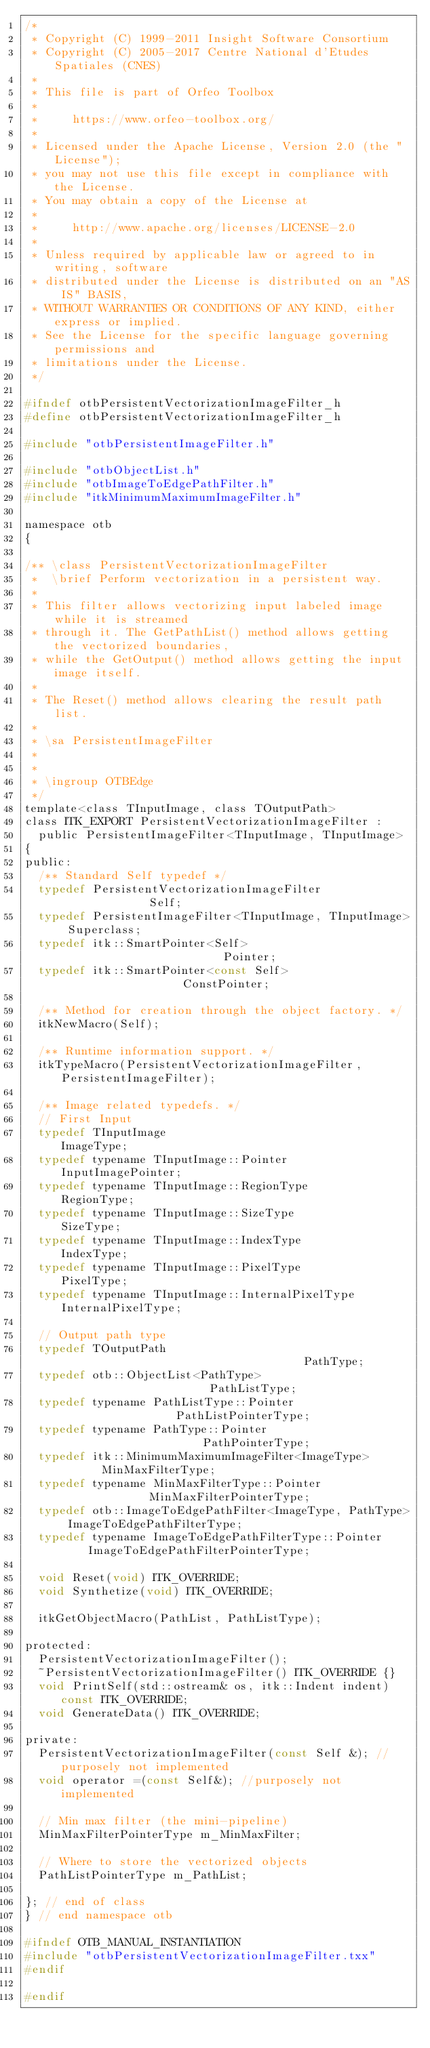Convert code to text. <code><loc_0><loc_0><loc_500><loc_500><_C_>/*
 * Copyright (C) 1999-2011 Insight Software Consortium
 * Copyright (C) 2005-2017 Centre National d'Etudes Spatiales (CNES)
 *
 * This file is part of Orfeo Toolbox
 *
 *     https://www.orfeo-toolbox.org/
 *
 * Licensed under the Apache License, Version 2.0 (the "License");
 * you may not use this file except in compliance with the License.
 * You may obtain a copy of the License at
 *
 *     http://www.apache.org/licenses/LICENSE-2.0
 *
 * Unless required by applicable law or agreed to in writing, software
 * distributed under the License is distributed on an "AS IS" BASIS,
 * WITHOUT WARRANTIES OR CONDITIONS OF ANY KIND, either express or implied.
 * See the License for the specific language governing permissions and
 * limitations under the License.
 */

#ifndef otbPersistentVectorizationImageFilter_h
#define otbPersistentVectorizationImageFilter_h

#include "otbPersistentImageFilter.h"

#include "otbObjectList.h"
#include "otbImageToEdgePathFilter.h"
#include "itkMinimumMaximumImageFilter.h"

namespace otb
{

/** \class PersistentVectorizationImageFilter
 *  \brief Perform vectorization in a persistent way.
 *
 * This filter allows vectorizing input labeled image while it is streamed
 * through it. The GetPathList() method allows getting the vectorized boundaries,
 * while the GetOutput() method allows getting the input image itself.
 *
 * The Reset() method allows clearing the result path list.
 *
 * \sa PersistentImageFilter
 *
 *
 * \ingroup OTBEdge
 */
template<class TInputImage, class TOutputPath>
class ITK_EXPORT PersistentVectorizationImageFilter :
  public PersistentImageFilter<TInputImage, TInputImage>
{
public:
  /** Standard Self typedef */
  typedef PersistentVectorizationImageFilter              Self;
  typedef PersistentImageFilter<TInputImage, TInputImage> Superclass;
  typedef itk::SmartPointer<Self>                         Pointer;
  typedef itk::SmartPointer<const Self>                   ConstPointer;

  /** Method for creation through the object factory. */
  itkNewMacro(Self);

  /** Runtime information support. */
  itkTypeMacro(PersistentVectorizationImageFilter, PersistentImageFilter);

  /** Image related typedefs. */
  // First Input
  typedef TInputImage                             ImageType;
  typedef typename TInputImage::Pointer           InputImagePointer;
  typedef typename TInputImage::RegionType        RegionType;
  typedef typename TInputImage::SizeType          SizeType;
  typedef typename TInputImage::IndexType         IndexType;
  typedef typename TInputImage::PixelType         PixelType;
  typedef typename TInputImage::InternalPixelType InternalPixelType;

  // Output path type
  typedef TOutputPath                                     PathType;
  typedef otb::ObjectList<PathType>                       PathListType;
  typedef typename PathListType::Pointer                  PathListPointerType;
  typedef typename PathType::Pointer                      PathPointerType;
  typedef itk::MinimumMaximumImageFilter<ImageType>       MinMaxFilterType;
  typedef typename MinMaxFilterType::Pointer              MinMaxFilterPointerType;
  typedef otb::ImageToEdgePathFilter<ImageType, PathType> ImageToEdgePathFilterType;
  typedef typename ImageToEdgePathFilterType::Pointer     ImageToEdgePathFilterPointerType;

  void Reset(void) ITK_OVERRIDE;
  void Synthetize(void) ITK_OVERRIDE;

  itkGetObjectMacro(PathList, PathListType);

protected:
  PersistentVectorizationImageFilter();
  ~PersistentVectorizationImageFilter() ITK_OVERRIDE {}
  void PrintSelf(std::ostream& os, itk::Indent indent) const ITK_OVERRIDE;
  void GenerateData() ITK_OVERRIDE;

private:
  PersistentVectorizationImageFilter(const Self &); //purposely not implemented
  void operator =(const Self&); //purposely not implemented

  // Min max filter (the mini-pipeline)
  MinMaxFilterPointerType m_MinMaxFilter;

  // Where to store the vectorized objects
  PathListPointerType m_PathList;

}; // end of class
} // end namespace otb

#ifndef OTB_MANUAL_INSTANTIATION
#include "otbPersistentVectorizationImageFilter.txx"
#endif

#endif
</code> 